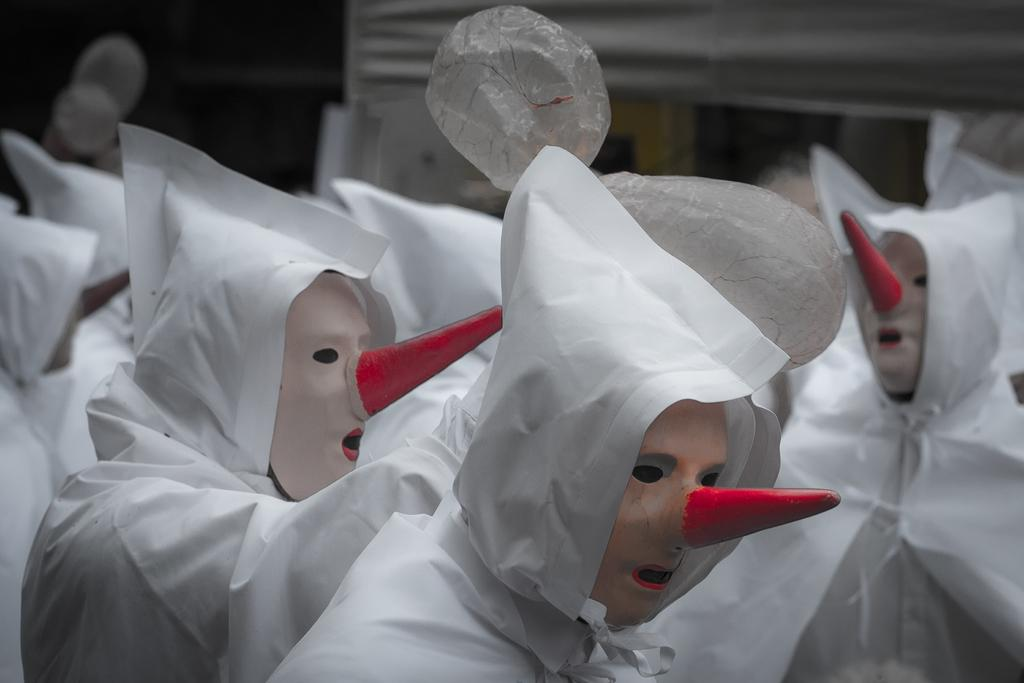What is present in the image? There are people in the image. What are the people wearing? The people are wearing white dresses and hats. What can be seen on the faces of the people? The people have masks on their faces. How many rings can be seen on the fingers of the girl in the image? There is no girl present in the image, and therefore no rings can be seen on her fingers. What type of wilderness can be seen in the background of the image? There is no wilderness present in the image; it features people wearing white dresses, hats, and masks. 